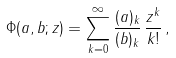<formula> <loc_0><loc_0><loc_500><loc_500>\Phi ( a , b ; z ) = \sum _ { k = 0 } ^ { \infty } \frac { ( a ) _ { k } } { ( b ) _ { k } } \, \frac { z ^ { k } } { k ! } \, ,</formula> 